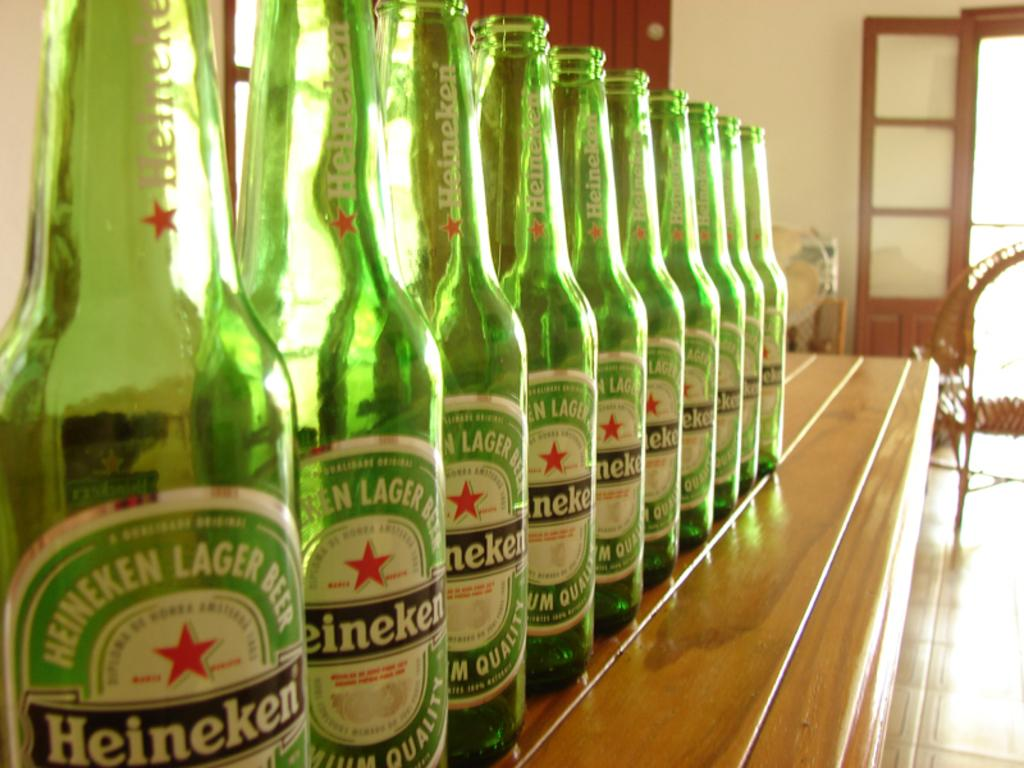<image>
Render a clear and concise summary of the photo. Many bottles of Heineken lager beer are lined up on a bar. 